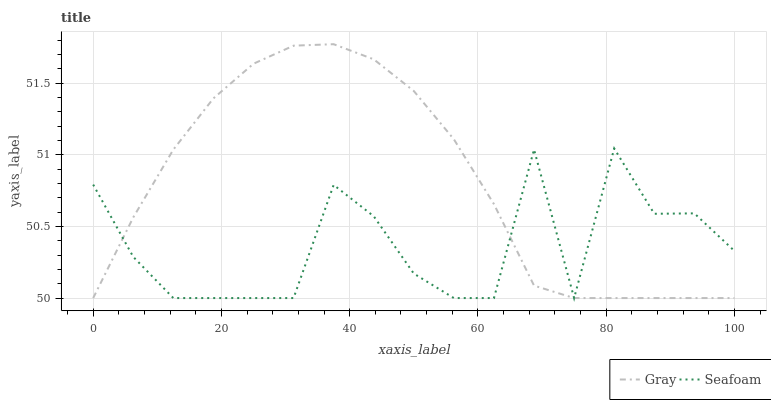Does Seafoam have the minimum area under the curve?
Answer yes or no. Yes. Does Gray have the maximum area under the curve?
Answer yes or no. Yes. Does Seafoam have the maximum area under the curve?
Answer yes or no. No. Is Gray the smoothest?
Answer yes or no. Yes. Is Seafoam the roughest?
Answer yes or no. Yes. Is Seafoam the smoothest?
Answer yes or no. No. Does Gray have the lowest value?
Answer yes or no. Yes. Does Gray have the highest value?
Answer yes or no. Yes. Does Seafoam have the highest value?
Answer yes or no. No. Does Seafoam intersect Gray?
Answer yes or no. Yes. Is Seafoam less than Gray?
Answer yes or no. No. Is Seafoam greater than Gray?
Answer yes or no. No. 